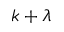Convert formula to latex. <formula><loc_0><loc_0><loc_500><loc_500>k + \lambda</formula> 